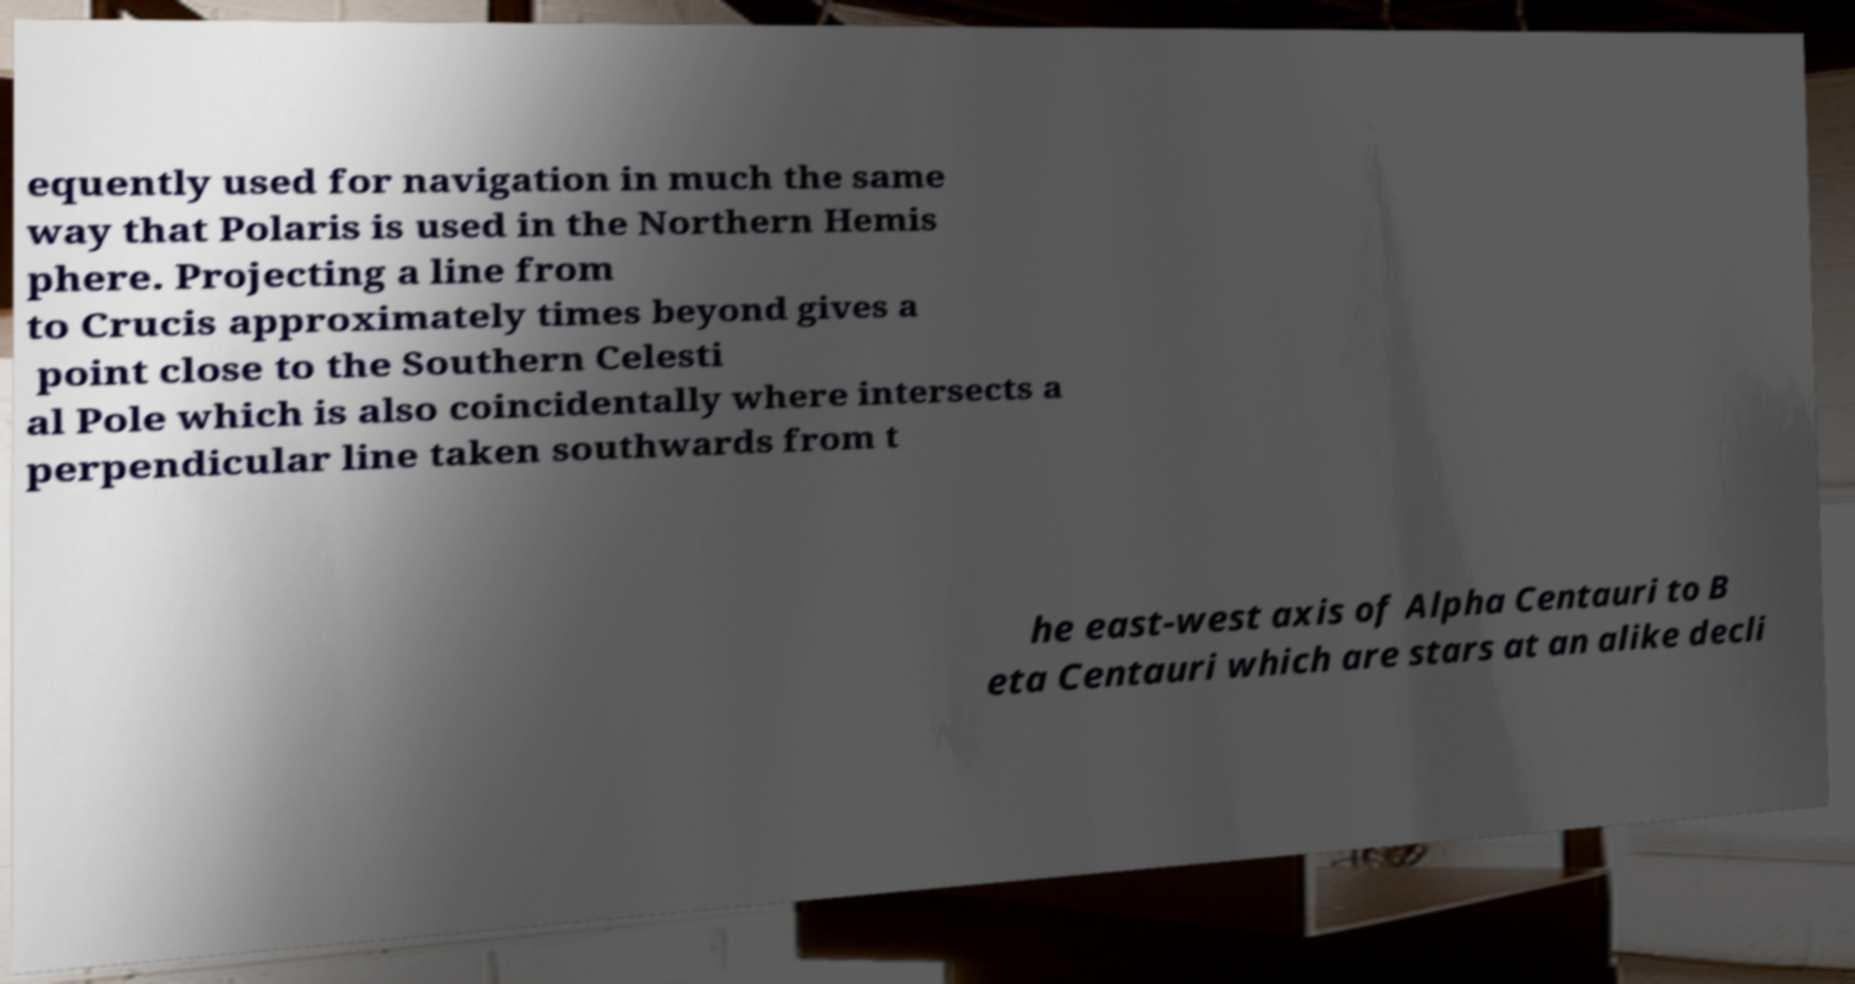Could you extract and type out the text from this image? equently used for navigation in much the same way that Polaris is used in the Northern Hemis phere. Projecting a line from to Crucis approximately times beyond gives a point close to the Southern Celesti al Pole which is also coincidentally where intersects a perpendicular line taken southwards from t he east-west axis of Alpha Centauri to B eta Centauri which are stars at an alike decli 